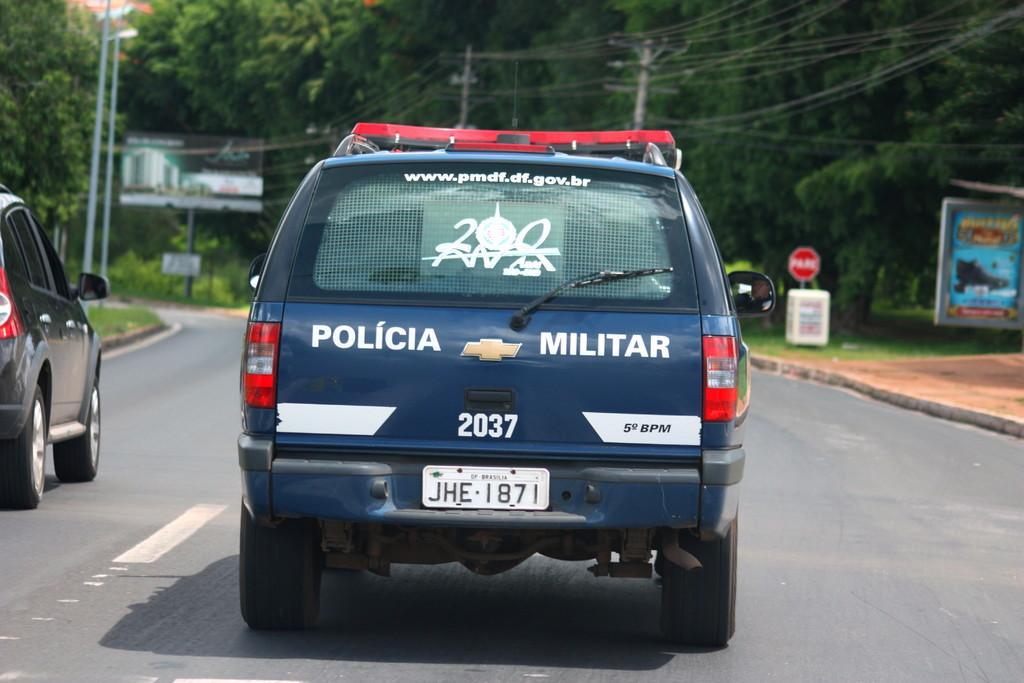Please provide a concise description of this image. In this image we can see some vehicles on the road. On the backside we can see some street poles, boards with pictures on it, the utility poles with wires, a signboard, a container, grass and a group of trees. 